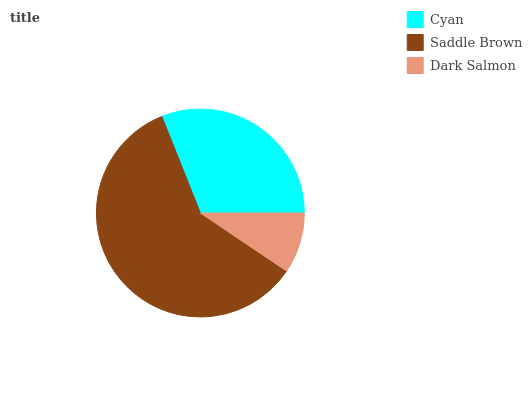Is Dark Salmon the minimum?
Answer yes or no. Yes. Is Saddle Brown the maximum?
Answer yes or no. Yes. Is Saddle Brown the minimum?
Answer yes or no. No. Is Dark Salmon the maximum?
Answer yes or no. No. Is Saddle Brown greater than Dark Salmon?
Answer yes or no. Yes. Is Dark Salmon less than Saddle Brown?
Answer yes or no. Yes. Is Dark Salmon greater than Saddle Brown?
Answer yes or no. No. Is Saddle Brown less than Dark Salmon?
Answer yes or no. No. Is Cyan the high median?
Answer yes or no. Yes. Is Cyan the low median?
Answer yes or no. Yes. Is Saddle Brown the high median?
Answer yes or no. No. Is Saddle Brown the low median?
Answer yes or no. No. 